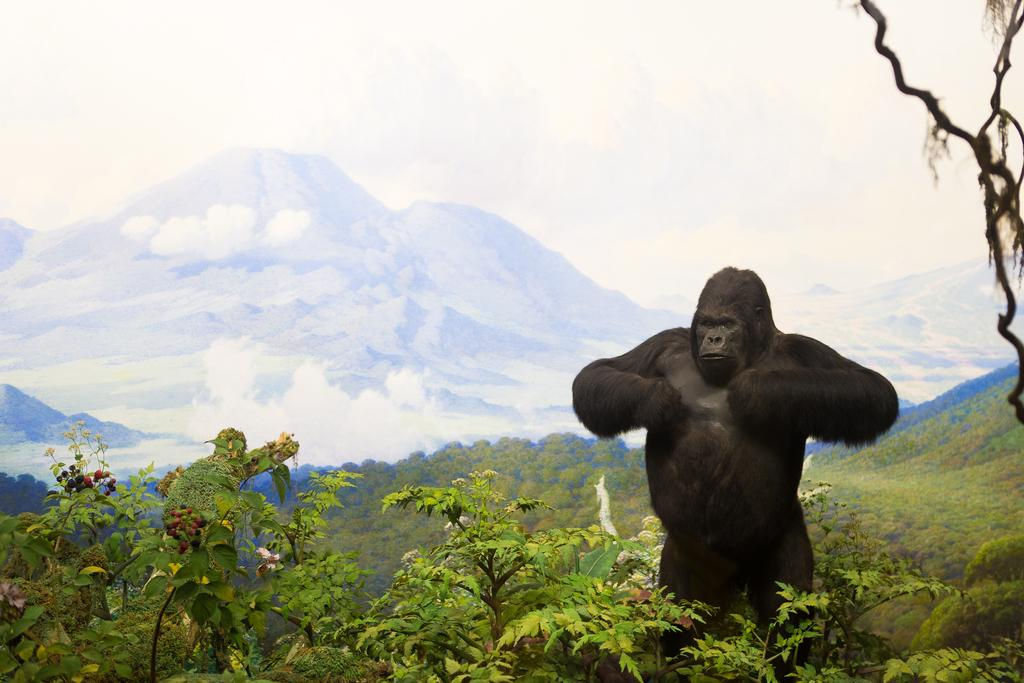What type of vegetation is at the bottom of the image? There are trees at the bottom of the image. What animal can be seen on the right side of the image? There is a gorilla on the right side of the image. What type of landscape is visible in the background of the image? There are hills in the background of the image. What is visible at the top of the image? The sky is visible at the top of the image. How many boys are playing with the gorilla in the image? There are no boys present in the image; it features a gorilla on the right side. What nation is depicted in the image? The image does not depict any specific nation; it shows a gorilla, trees, hills, and the sky. 